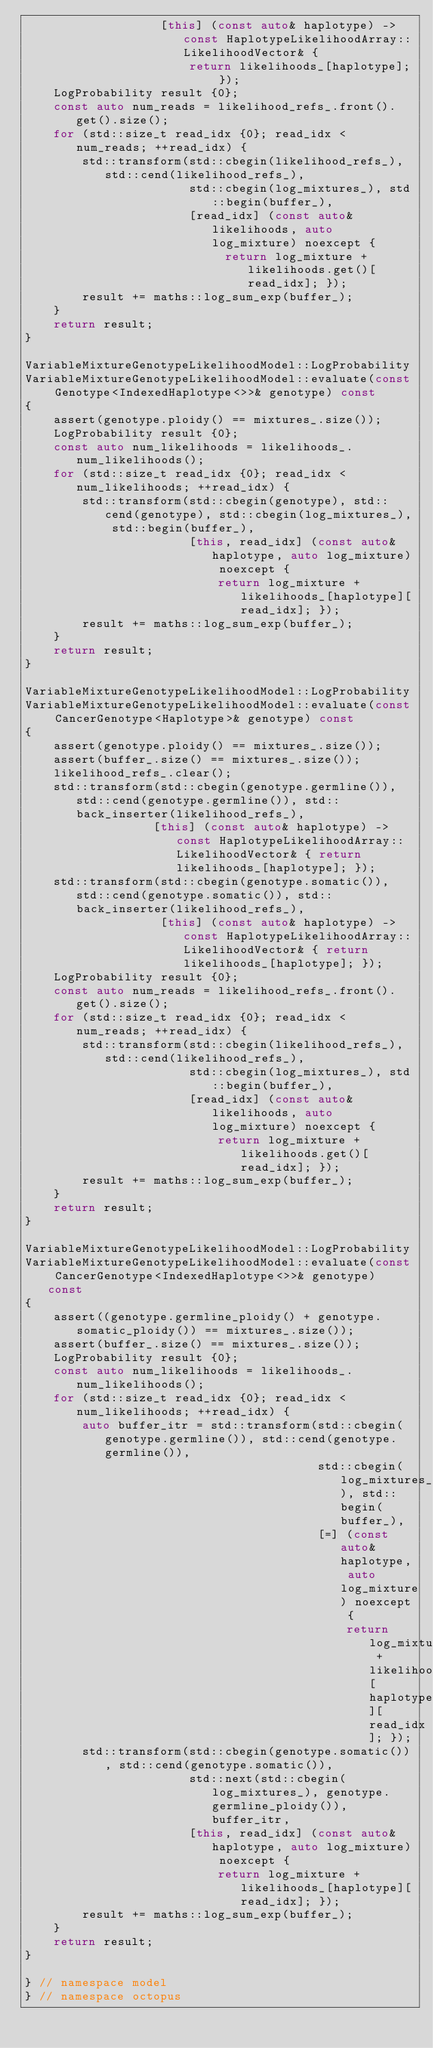<code> <loc_0><loc_0><loc_500><loc_500><_C++_>                   [this] (const auto& haplotype) -> const HaplotypeLikelihoodArray::LikelihoodVector& {
                       return likelihoods_[haplotype]; });
    LogProbability result {0};
    const auto num_reads = likelihood_refs_.front().get().size();
    for (std::size_t read_idx {0}; read_idx < num_reads; ++read_idx) {
        std::transform(std::cbegin(likelihood_refs_), std::cend(likelihood_refs_),
                       std::cbegin(log_mixtures_), std::begin(buffer_),
                       [read_idx] (const auto& likelihoods, auto log_mixture) noexcept {
                            return log_mixture + likelihoods.get()[read_idx]; });
        result += maths::log_sum_exp(buffer_);
    }
    return result;
}

VariableMixtureGenotypeLikelihoodModel::LogProbability
VariableMixtureGenotypeLikelihoodModel::evaluate(const Genotype<IndexedHaplotype<>>& genotype) const
{
    assert(genotype.ploidy() == mixtures_.size());
    LogProbability result {0};
    const auto num_likelihoods = likelihoods_.num_likelihoods();
    for (std::size_t read_idx {0}; read_idx < num_likelihoods; ++read_idx) {
        std::transform(std::cbegin(genotype), std::cend(genotype), std::cbegin(log_mixtures_), std::begin(buffer_),
                       [this, read_idx] (const auto& haplotype, auto log_mixture) noexcept {
                           return log_mixture + likelihoods_[haplotype][read_idx]; });
        result += maths::log_sum_exp(buffer_);
    }
    return result;
}

VariableMixtureGenotypeLikelihoodModel::LogProbability
VariableMixtureGenotypeLikelihoodModel::evaluate(const CancerGenotype<Haplotype>& genotype) const
{
    assert(genotype.ploidy() == mixtures_.size());
    assert(buffer_.size() == mixtures_.size());
    likelihood_refs_.clear();
    std::transform(std::cbegin(genotype.germline()), std::cend(genotype.germline()), std::back_inserter(likelihood_refs_),
                  [this] (const auto& haplotype) -> const HaplotypeLikelihoodArray::LikelihoodVector& { return likelihoods_[haplotype]; });
    std::transform(std::cbegin(genotype.somatic()), std::cend(genotype.somatic()), std::back_inserter(likelihood_refs_),
                   [this] (const auto& haplotype) -> const HaplotypeLikelihoodArray::LikelihoodVector& { return likelihoods_[haplotype]; });
    LogProbability result {0};
    const auto num_reads = likelihood_refs_.front().get().size();
    for (std::size_t read_idx {0}; read_idx < num_reads; ++read_idx) {
        std::transform(std::cbegin(likelihood_refs_), std::cend(likelihood_refs_),
                       std::cbegin(log_mixtures_), std::begin(buffer_),
                       [read_idx] (const auto& likelihoods, auto log_mixture) noexcept {
                           return log_mixture + likelihoods.get()[read_idx]; });
        result += maths::log_sum_exp(buffer_);
    }
    return result;
}

VariableMixtureGenotypeLikelihoodModel::LogProbability
VariableMixtureGenotypeLikelihoodModel::evaluate(const CancerGenotype<IndexedHaplotype<>>& genotype) const
{
    assert((genotype.germline_ploidy() + genotype.somatic_ploidy()) == mixtures_.size());
    assert(buffer_.size() == mixtures_.size());
    LogProbability result {0};
    const auto num_likelihoods = likelihoods_.num_likelihoods();
    for (std::size_t read_idx {0}; read_idx < num_likelihoods; ++read_idx) {
        auto buffer_itr = std::transform(std::cbegin(genotype.germline()), std::cend(genotype.germline()),
                                         std::cbegin(log_mixtures_), std::begin(buffer_),
                                         [=] (const auto& haplotype, auto log_mixture) noexcept {
                                             return log_mixture + likelihoods_[haplotype][read_idx]; });
        std::transform(std::cbegin(genotype.somatic()), std::cend(genotype.somatic()),
                       std::next(std::cbegin(log_mixtures_), genotype.germline_ploidy()), buffer_itr,
                       [this, read_idx] (const auto& haplotype, auto log_mixture) noexcept {
                           return log_mixture + likelihoods_[haplotype][read_idx]; });
        result += maths::log_sum_exp(buffer_);
    }
    return result;
}

} // namespace model
} // namespace octopus
</code> 